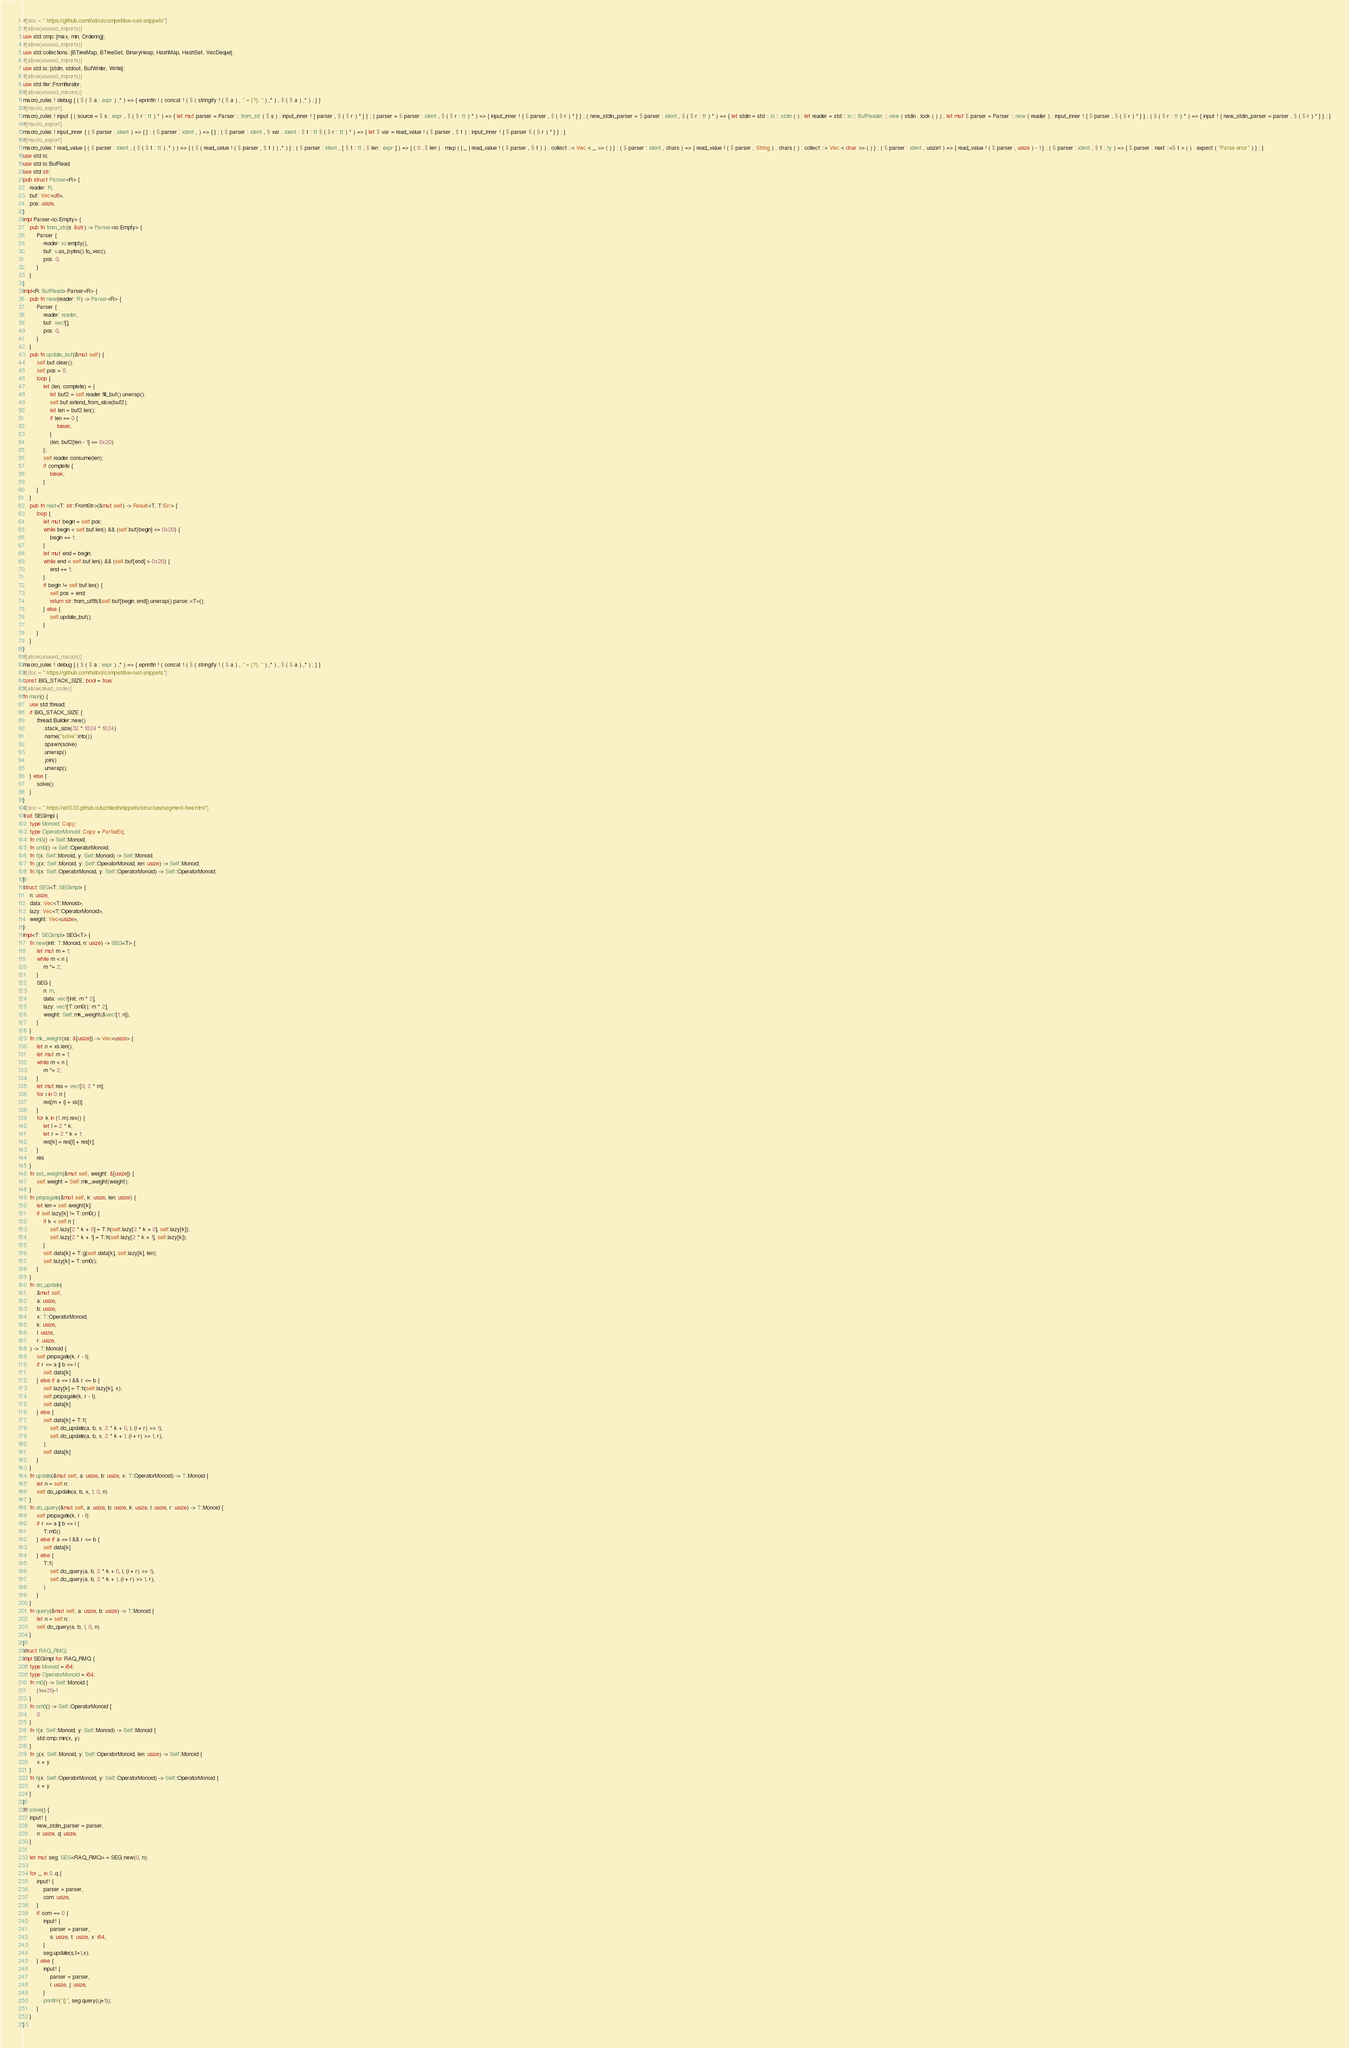<code> <loc_0><loc_0><loc_500><loc_500><_Rust_>#[doc = " https://github.com/hatoo/competitive-rust-snippets"]
#[allow(unused_imports)]
use std::cmp::{max, min, Ordering};
#[allow(unused_imports)]
use std::collections::{BTreeMap, BTreeSet, BinaryHeap, HashMap, HashSet, VecDeque};
#[allow(unused_imports)]
use std::io::{stdin, stdout, BufWriter, Write};
#[allow(unused_imports)]
use std::iter::FromIterator;
#[allow(unused_macros)]
macro_rules ! debug { ( $ ( $ a : expr ) ,* ) => { eprintln ! ( concat ! ( $ ( stringify ! ( $ a ) , " = {:?}, " ) ,* ) , $ ( $ a ) ,* ) ; } }
#[macro_export]
macro_rules ! input { ( source = $ s : expr , $ ( $ r : tt ) * ) => { let mut parser = Parser :: from_str ( $ s ) ; input_inner ! { parser , $ ( $ r ) * } } ; ( parser = $ parser : ident , $ ( $ r : tt ) * ) => { input_inner ! { $ parser , $ ( $ r ) * } } ; ( new_stdin_parser = $ parser : ident , $ ( $ r : tt ) * ) => { let stdin = std :: io :: stdin ( ) ; let reader = std :: io :: BufReader :: new ( stdin . lock ( ) ) ; let mut $ parser = Parser :: new ( reader ) ; input_inner ! { $ parser , $ ( $ r ) * } } ; ( $ ( $ r : tt ) * ) => { input ! { new_stdin_parser = parser , $ ( $ r ) * } } ; }
#[macro_export]
macro_rules ! input_inner { ( $ parser : ident ) => { } ; ( $ parser : ident , ) => { } ; ( $ parser : ident , $ var : ident : $ t : tt $ ( $ r : tt ) * ) => { let $ var = read_value ! ( $ parser , $ t ) ; input_inner ! { $ parser $ ( $ r ) * } } ; }
#[macro_export]
macro_rules ! read_value { ( $ parser : ident , ( $ ( $ t : tt ) ,* ) ) => { ( $ ( read_value ! ( $ parser , $ t ) ) ,* ) } ; ( $ parser : ident , [ $ t : tt ; $ len : expr ] ) => { ( 0 ..$ len ) . map ( | _ | read_value ! ( $ parser , $ t ) ) . collect ::< Vec < _ >> ( ) } ; ( $ parser : ident , chars ) => { read_value ! ( $ parser , String ) . chars ( ) . collect ::< Vec < char >> ( ) } ; ( $ parser : ident , usize1 ) => { read_value ! ( $ parser , usize ) - 1 } ; ( $ parser : ident , $ t : ty ) => { $ parser . next ::<$ t > ( ) . expect ( "Parse error" ) } ; }
use std::io;
use std::io::BufRead;
use std::str;
pub struct Parser<R> {
    reader: R,
    buf: Vec<u8>,
    pos: usize,
}
impl Parser<io::Empty> {
    pub fn from_str(s: &str) -> Parser<io::Empty> {
        Parser {
            reader: io::empty(),
            buf: s.as_bytes().to_vec(),
            pos: 0,
        }
    }
}
impl<R: BufRead> Parser<R> {
    pub fn new(reader: R) -> Parser<R> {
        Parser {
            reader: reader,
            buf: vec![],
            pos: 0,
        }
    }
    pub fn update_buf(&mut self) {
        self.buf.clear();
        self.pos = 0;
        loop {
            let (len, complete) = {
                let buf2 = self.reader.fill_buf().unwrap();
                self.buf.extend_from_slice(buf2);
                let len = buf2.len();
                if len == 0 {
                    break;
                }
                (len, buf2[len - 1] <= 0x20)
            };
            self.reader.consume(len);
            if complete {
                break;
            }
        }
    }
    pub fn next<T: str::FromStr>(&mut self) -> Result<T, T::Err> {
        loop {
            let mut begin = self.pos;
            while begin < self.buf.len() && (self.buf[begin] <= 0x20) {
                begin += 1;
            }
            let mut end = begin;
            while end < self.buf.len() && (self.buf[end] > 0x20) {
                end += 1;
            }
            if begin != self.buf.len() {
                self.pos = end;
                return str::from_utf8(&self.buf[begin..end]).unwrap().parse::<T>();
            } else {
                self.update_buf();
            }
        }
    }
}
#[allow(unused_macros)]
macro_rules ! debug { ( $ ( $ a : expr ) ,* ) => { eprintln ! ( concat ! ( $ ( stringify ! ( $ a ) , " = {:?}, " ) ,* ) , $ ( $ a ) ,* ) ; } }
#[doc = " https://github.com/hatoo/competitive-rust-snippets"]
const BIG_STACK_SIZE: bool = true;
#[allow(dead_code)]
fn main() {
    use std::thread;
    if BIG_STACK_SIZE {
        thread::Builder::new()
            .stack_size(32 * 1024 * 1024)
            .name("solve".into())
            .spawn(solve)
            .unwrap()
            .join()
            .unwrap();
    } else {
        solve();
    }
}
#[doc = " https://ei1333.github.io/luzhiled/snippets/structure/segment-tree.html"]
trait SEGImpl {
    type Monoid: Copy;
    type OperatorMonoid: Copy + PartialEq;
    fn m0() -> Self::Monoid;
    fn om0() -> Self::OperatorMonoid;
    fn f(x: Self::Monoid, y: Self::Monoid) -> Self::Monoid;
    fn g(x: Self::Monoid, y: Self::OperatorMonoid, len: usize) -> Self::Monoid;
    fn h(x: Self::OperatorMonoid, y: Self::OperatorMonoid) -> Self::OperatorMonoid;
}
struct SEG<T: SEGImpl> {
    n: usize,
    data: Vec<T::Monoid>,
    lazy: Vec<T::OperatorMonoid>,
    weight: Vec<usize>,
}
impl<T: SEGImpl> SEG<T> {
    fn new(init: T::Monoid, n: usize) -> SEG<T> {
        let mut m = 1;
        while m < n {
            m *= 2;
        }
        SEG {
            n: m,
            data: vec![init; m * 2],
            lazy: vec![T::om0(); m * 2],
            weight: Self::mk_weight(&vec![1; n]),
        }
    }
    fn mk_weight(xs: &[usize]) -> Vec<usize> {
        let n = xs.len();
        let mut m = 1;
        while m < n {
            m *= 2;
        }
        let mut res = vec![0; 2 * m];
        for i in 0..n {
            res[m + i] = xs[i];
        }
        for k in (1..m).rev() {
            let l = 2 * k;
            let r = 2 * k + 1;
            res[k] = res[l] + res[r];
        }
        res
    }
    fn set_weight(&mut self, weight: &[usize]) {
        self.weight = Self::mk_weight(weight);
    }
    fn propagate(&mut self, k: usize, len: usize) {
        let len = self.weight[k];
        if self.lazy[k] != T::om0() {
            if k < self.n {
                self.lazy[2 * k + 0] = T::h(self.lazy[2 * k + 0], self.lazy[k]);
                self.lazy[2 * k + 1] = T::h(self.lazy[2 * k + 1], self.lazy[k]);
            }
            self.data[k] = T::g(self.data[k], self.lazy[k], len);
            self.lazy[k] = T::om0();
        }
    }
    fn do_update(
        &mut self,
        a: usize,
        b: usize,
        x: T::OperatorMonoid,
        k: usize,
        l: usize,
        r: usize,
    ) -> T::Monoid {
        self.propagate(k, r - l);
        if r <= a || b <= l {
            self.data[k]
        } else if a <= l && r <= b {
            self.lazy[k] = T::h(self.lazy[k], x);
            self.propagate(k, r - l);
            self.data[k]
        } else {
            self.data[k] = T::f(
                self.do_update(a, b, x, 2 * k + 0, l, (l + r) >> 1),
                self.do_update(a, b, x, 2 * k + 1, (l + r) >> 1, r),
            );
            self.data[k]
        }
    }
    fn update(&mut self, a: usize, b: usize, x: T::OperatorMonoid) -> T::Monoid {
        let n = self.n;
        self.do_update(a, b, x, 1, 0, n)
    }
    fn do_query(&mut self, a: usize, b: usize, k: usize, l: usize, r: usize) -> T::Monoid {
        self.propagate(k, r - l);
        if r <= a || b <= l {
            T::m0()
        } else if a <= l && r <= b {
            self.data[k]
        } else {
            T::f(
                self.do_query(a, b, 2 * k + 0, l, (l + r) >> 1),
                self.do_query(a, b, 2 * k + 1, (l + r) >> 1, r),
            )
        }
    }
    fn query(&mut self, a: usize, b: usize) -> T::Monoid {
        let n = self.n;
        self.do_query(a, b, 1, 0, n)
    }
}
struct RAQ_RMQ;
impl SEGImpl for RAQ_RMQ { 
    type Monoid = i64;
    type OperatorMonoid = i64;
    fn m0() -> Self::Monoid {
        (1<<31)-1
    }
    fn om0() -> Self::OperatorMonoid {
        0
    }
    fn f(x: Self::Monoid, y: Self::Monoid) -> Self::Monoid {
        std::cmp::min(x, y)
    }
    fn g(x: Self::Monoid, y: Self::OperatorMonoid, len: usize) -> Self::Monoid {
        x + y
    }
    fn h(x: Self::OperatorMonoid, y: Self::OperatorMonoid) -> Self::OperatorMonoid {
        x + y
    }
}
fn solve() {
    input! {
        new_stdin_parser = parser,
        n: usize, q: usize,
    }

    let mut seg: SEG<RAQ_RMQ> = SEG::new(0, n);

    for _ in 0..q {
        input! {
            parser = parser,
            com: usize,
        }
        if com == 0 {
            input! {
                parser = parser,
                s: usize, t: usize, x: i64,
            }
            seg.update(s,t+1,x);
        } else {
            input! {
                parser = parser,
                i: usize, j: usize,
            }
            println!("{}", seg.query(i,j+1));
        }
    }
}
</code> 